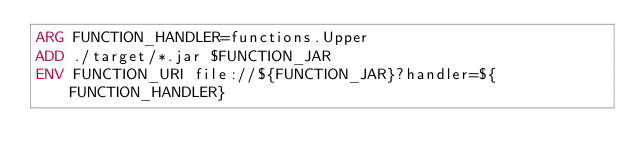Convert code to text. <code><loc_0><loc_0><loc_500><loc_500><_Dockerfile_>ARG FUNCTION_HANDLER=functions.Upper
ADD ./target/*.jar $FUNCTION_JAR
ENV FUNCTION_URI file://${FUNCTION_JAR}?handler=${FUNCTION_HANDLER}
</code> 